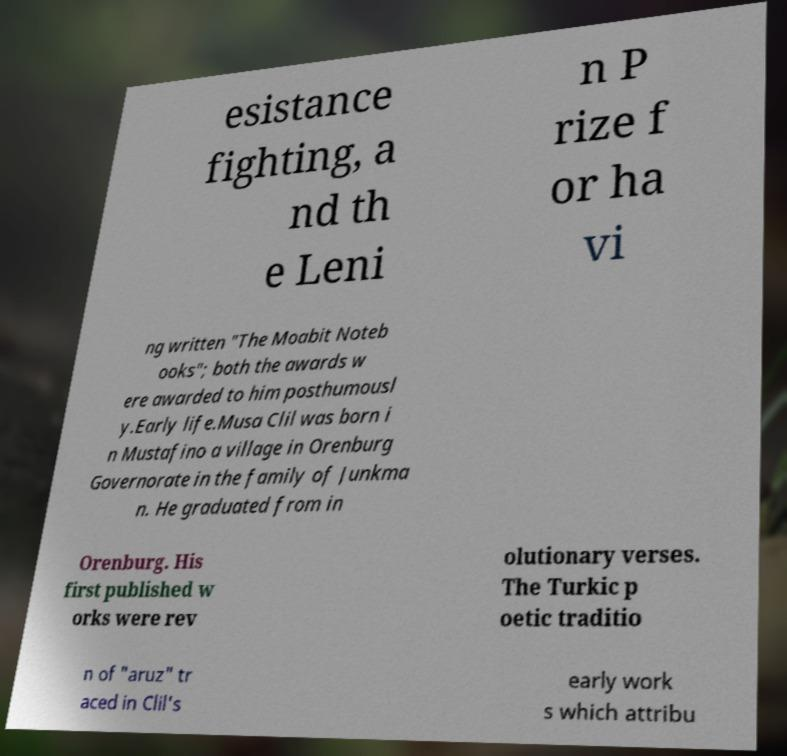Can you read and provide the text displayed in the image?This photo seems to have some interesting text. Can you extract and type it out for me? esistance fighting, a nd th e Leni n P rize f or ha vi ng written "The Moabit Noteb ooks"; both the awards w ere awarded to him posthumousl y.Early life.Musa Clil was born i n Mustafino a village in Orenburg Governorate in the family of Junkma n. He graduated from in Orenburg. His first published w orks were rev olutionary verses. The Turkic p oetic traditio n of "aruz" tr aced in Clil's early work s which attribu 